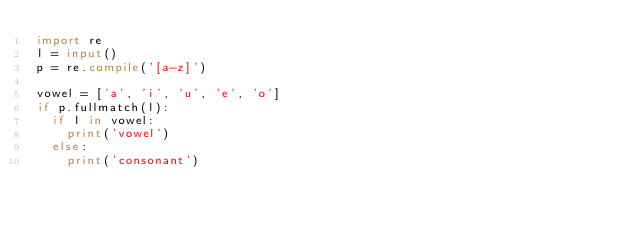Convert code to text. <code><loc_0><loc_0><loc_500><loc_500><_Python_>import re
l = input()
p = re.compile('[a-z]')

vowel = ['a', 'i', 'u', 'e', 'o']
if p.fullmatch(l):
  if l in vowel:
    print('vowel')
  else:
    print('consonant')</code> 